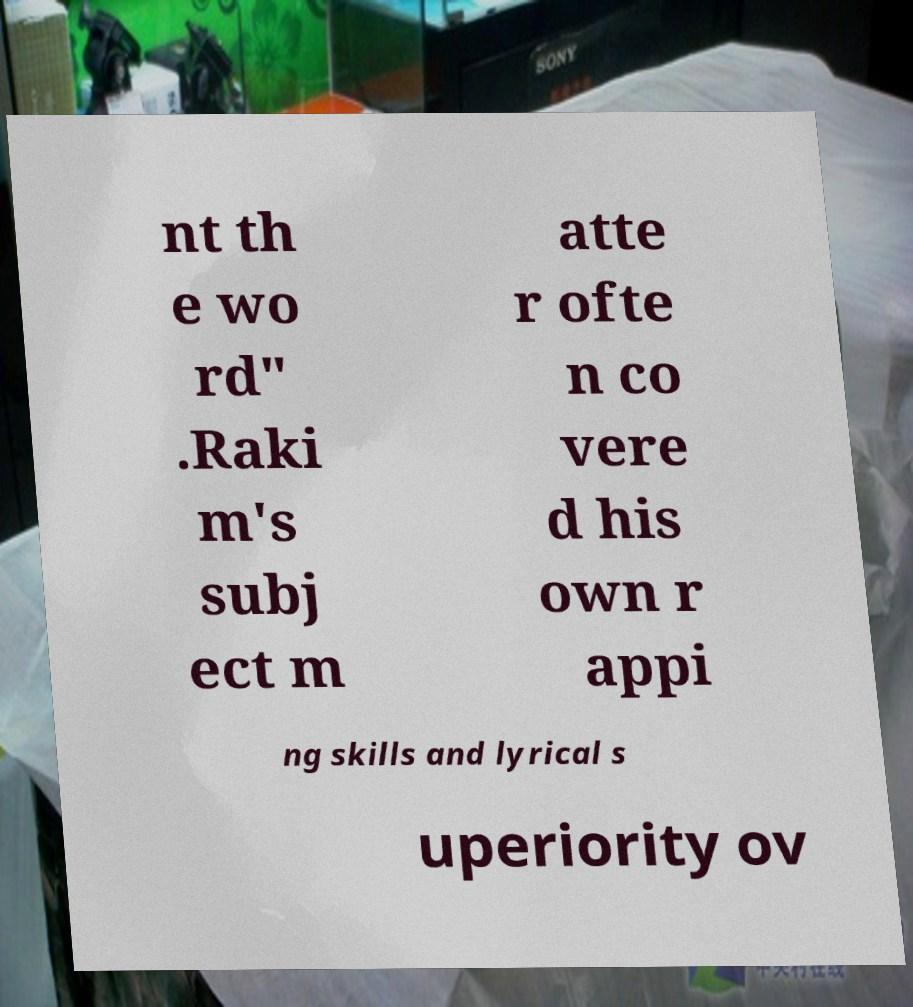Can you read and provide the text displayed in the image?This photo seems to have some interesting text. Can you extract and type it out for me? nt th e wo rd" .Raki m's subj ect m atte r ofte n co vere d his own r appi ng skills and lyrical s uperiority ov 